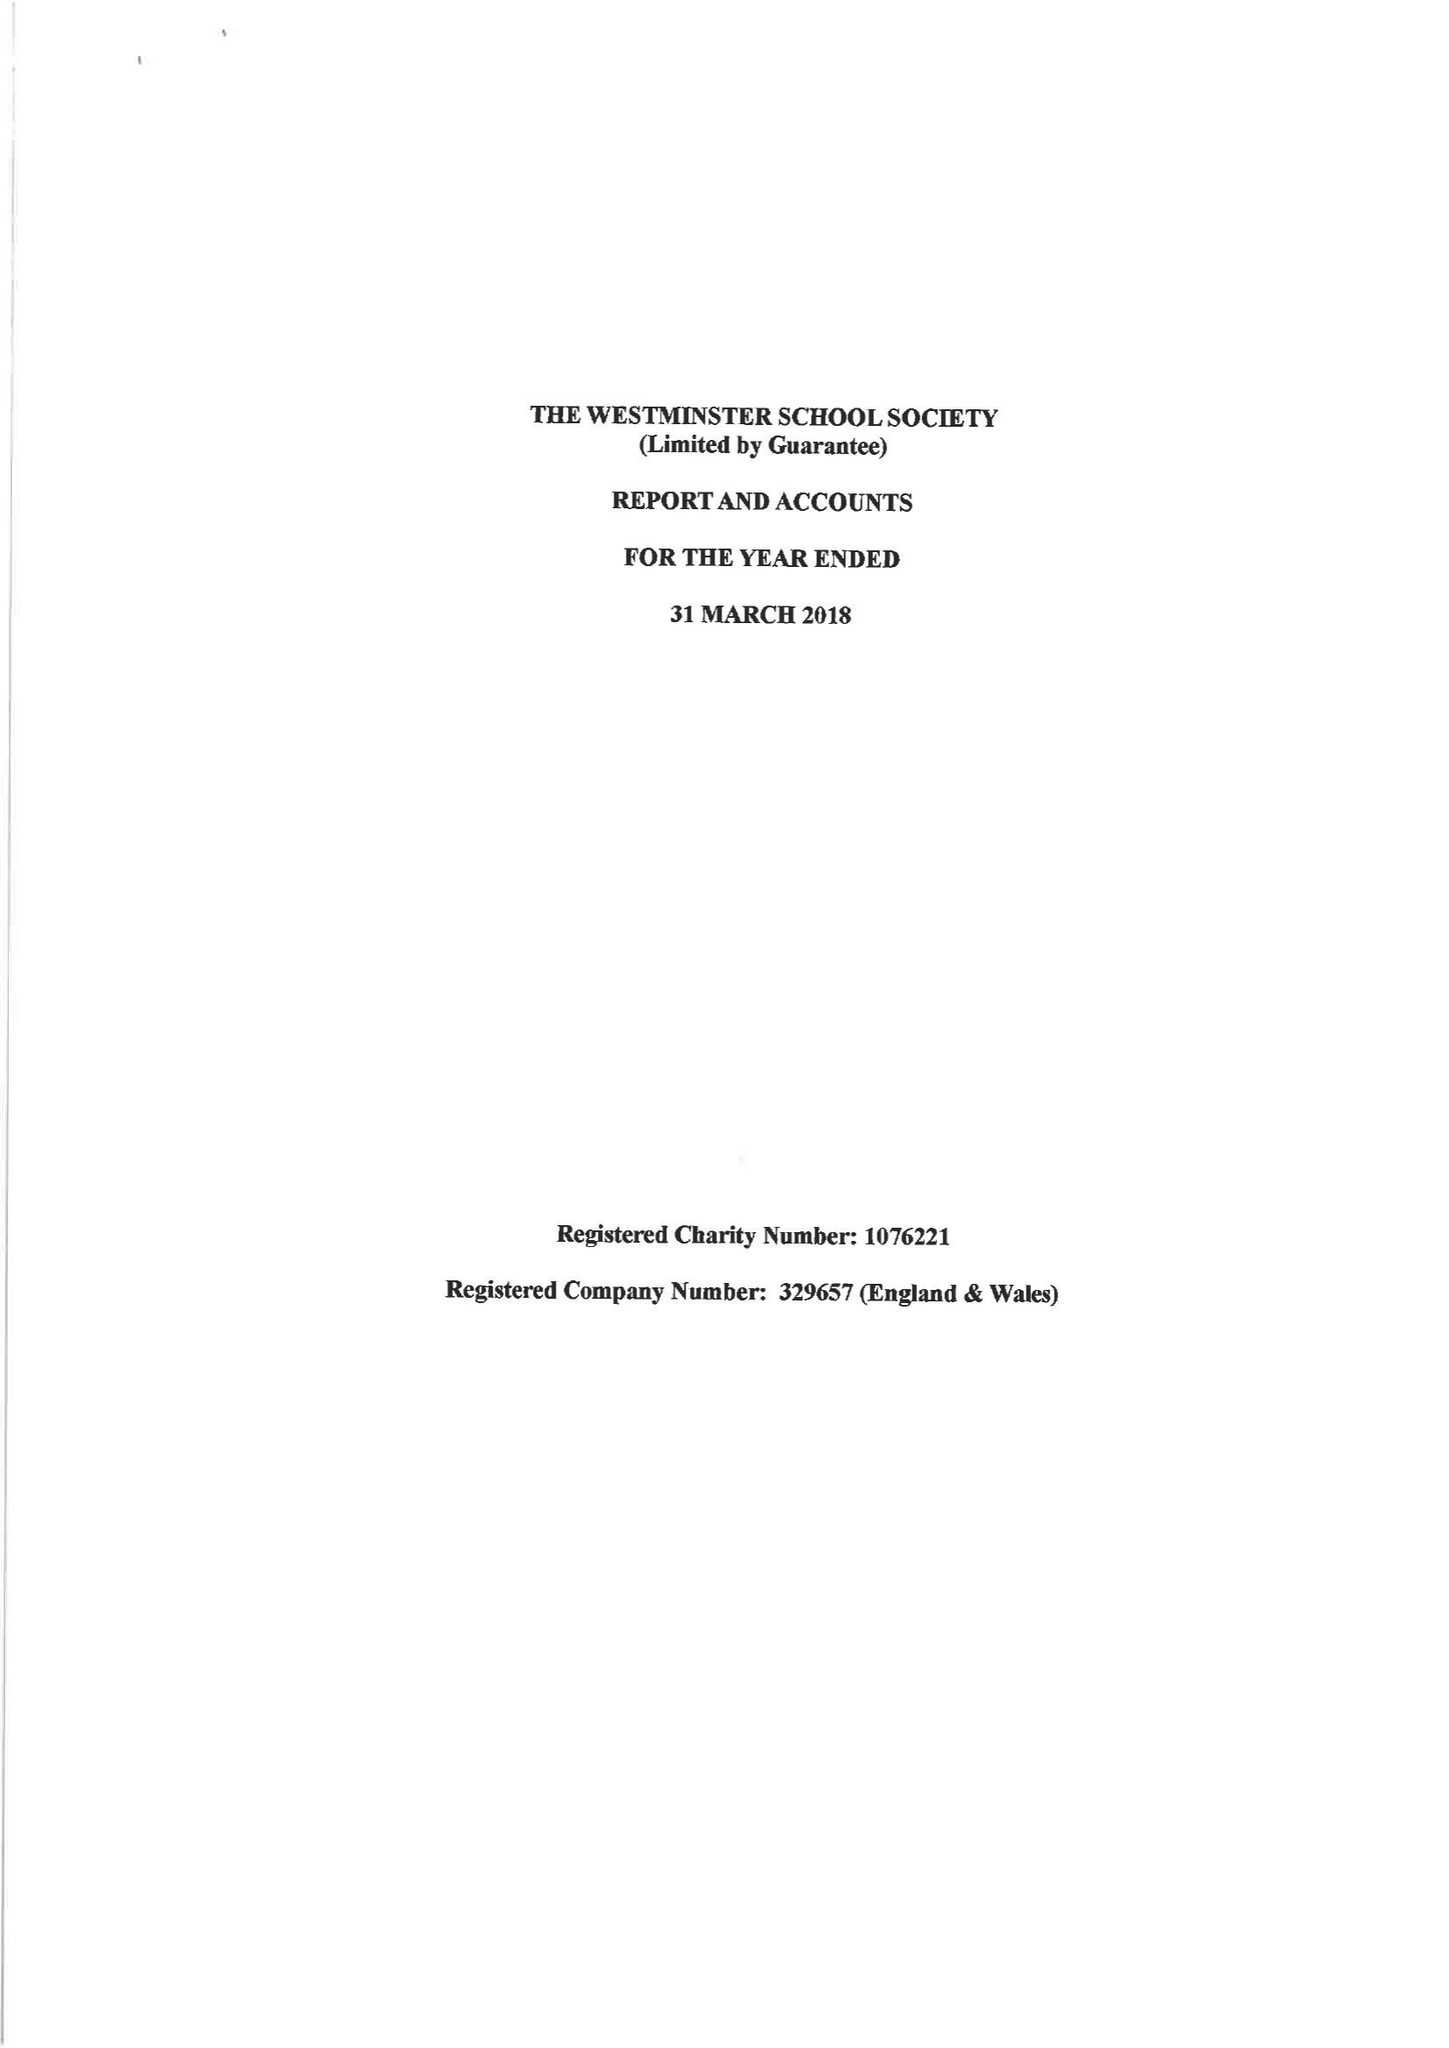What is the value for the charity_number?
Answer the question using a single word or phrase. 1076221 